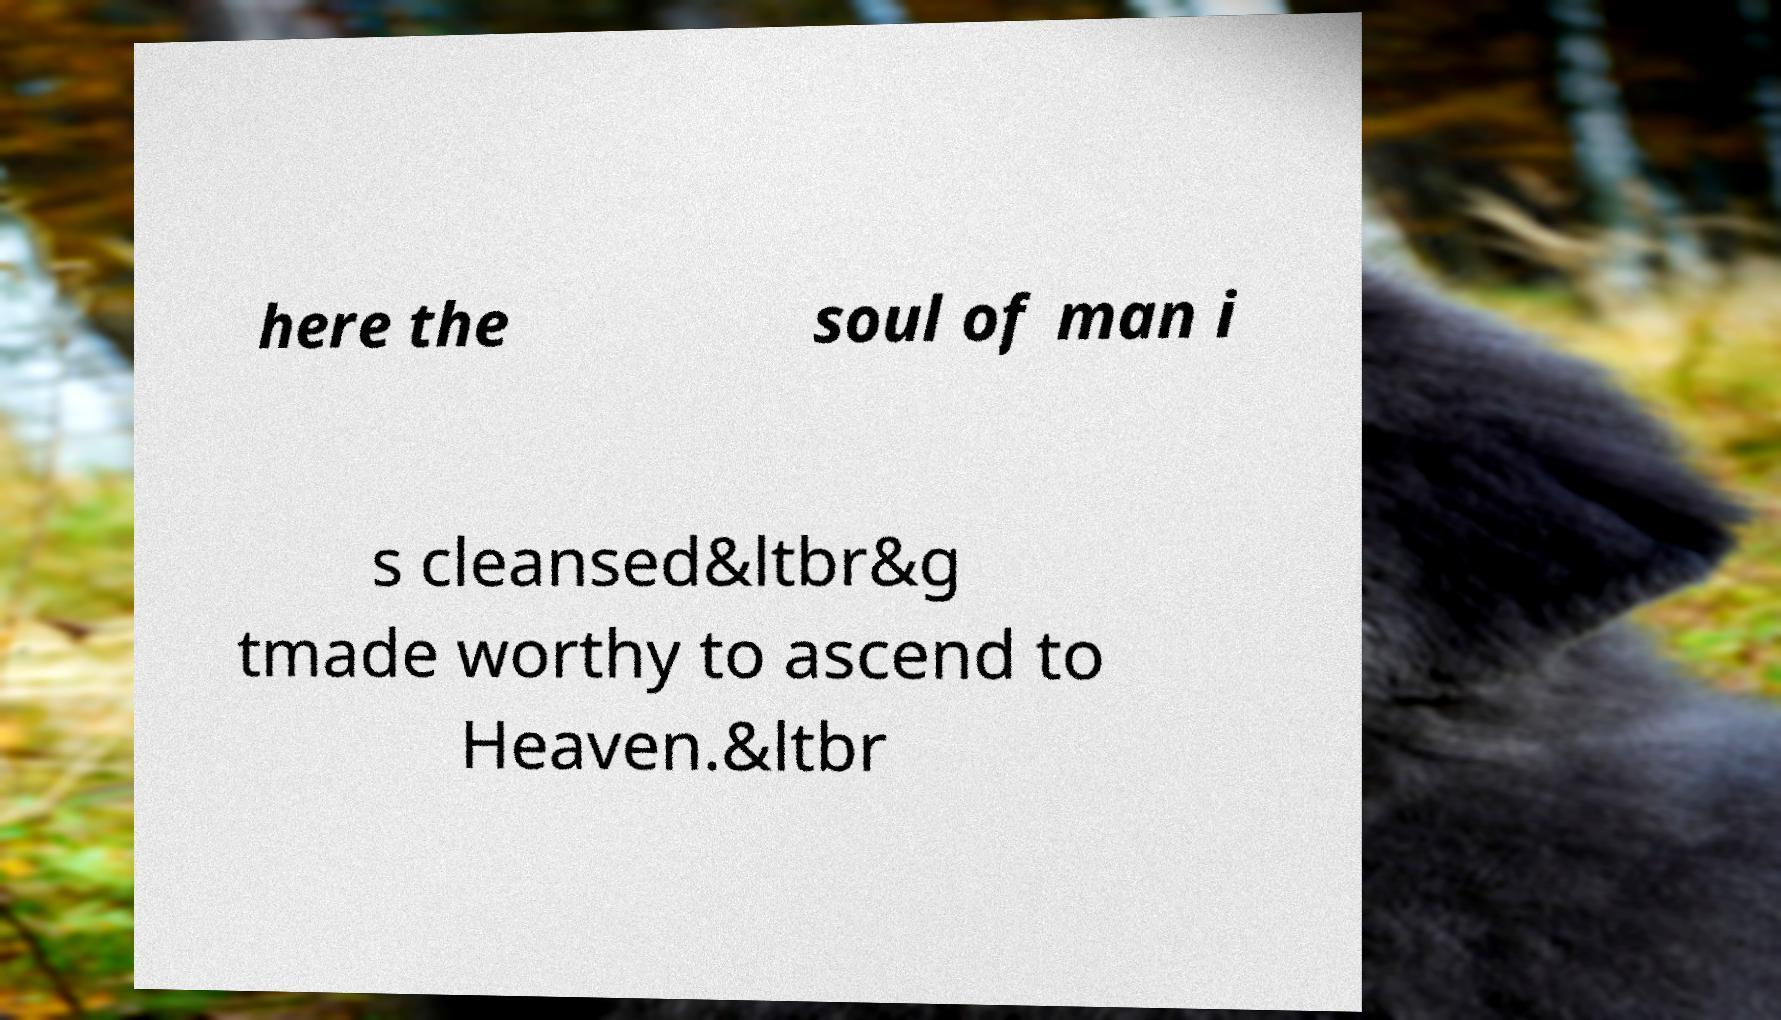Please identify and transcribe the text found in this image. here the soul of man i s cleansed&ltbr&g tmade worthy to ascend to Heaven.&ltbr 